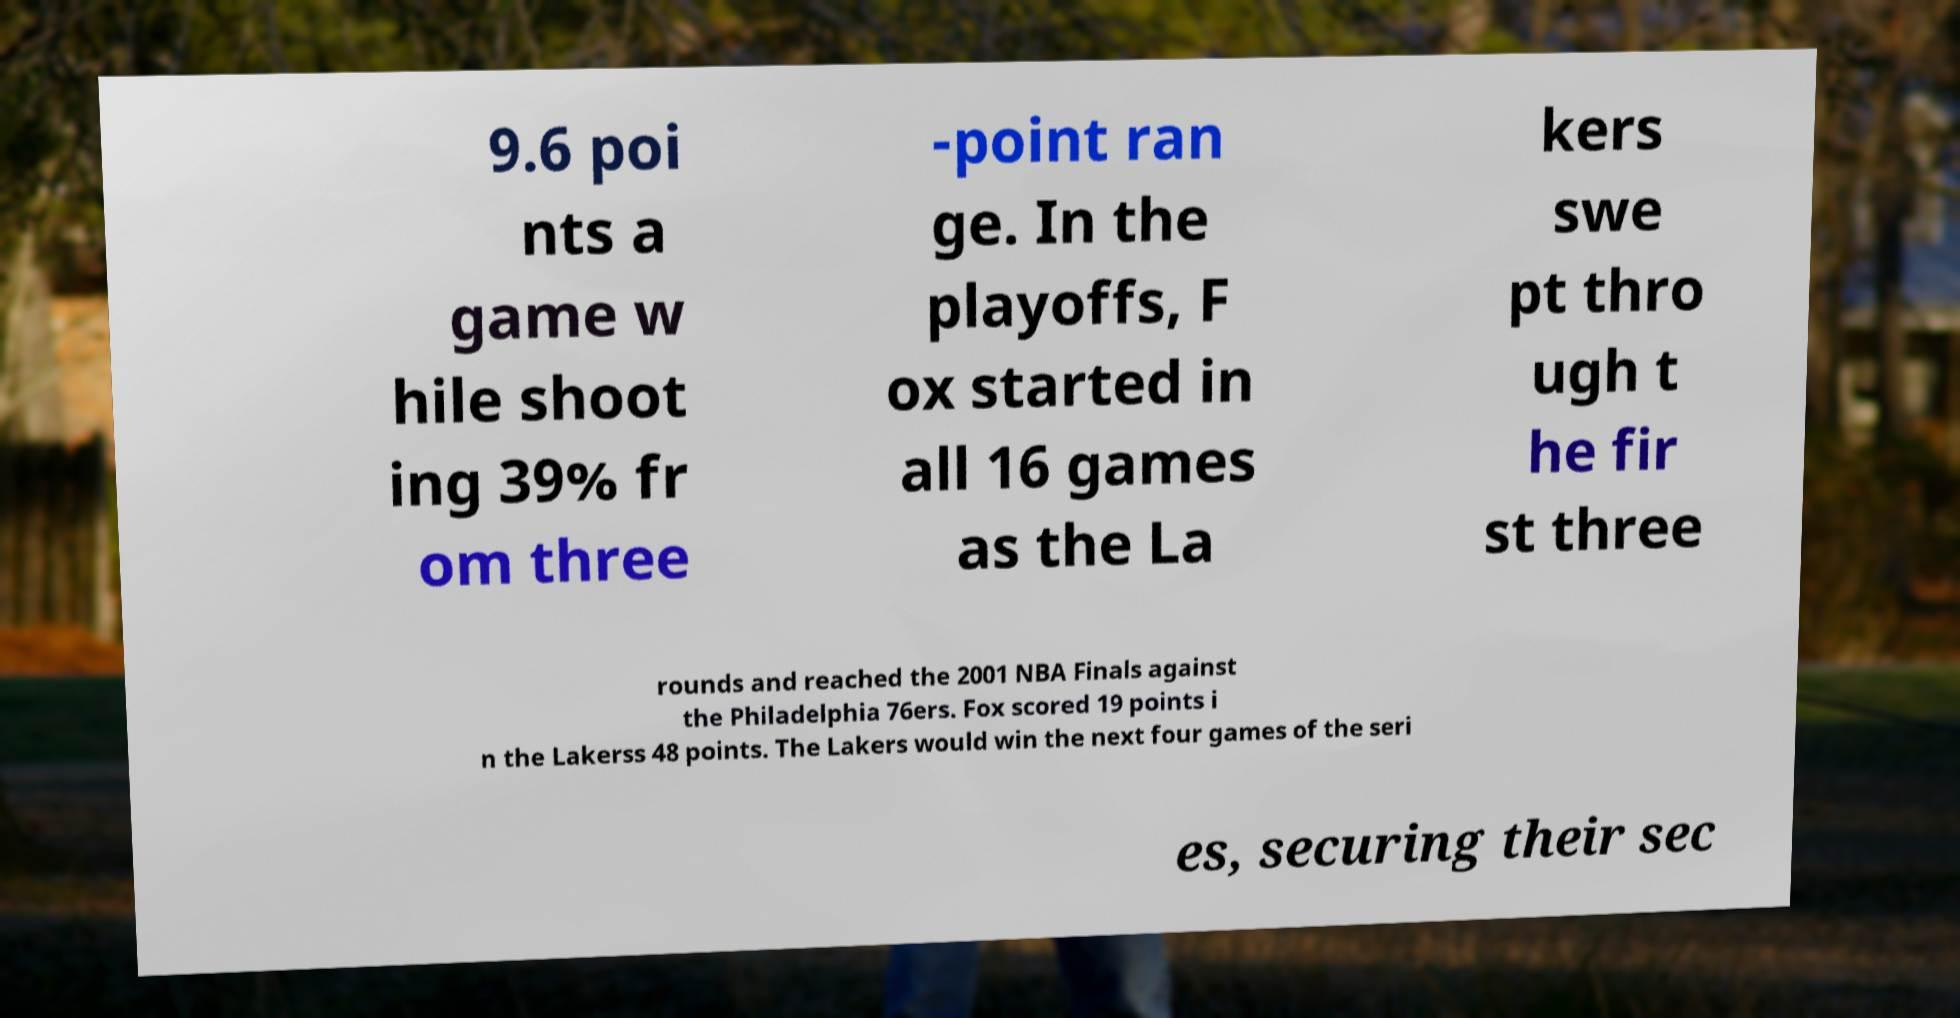What messages or text are displayed in this image? I need them in a readable, typed format. 9.6 poi nts a game w hile shoot ing 39% fr om three -point ran ge. In the playoffs, F ox started in all 16 games as the La kers swe pt thro ugh t he fir st three rounds and reached the 2001 NBA Finals against the Philadelphia 76ers. Fox scored 19 points i n the Lakerss 48 points. The Lakers would win the next four games of the seri es, securing their sec 